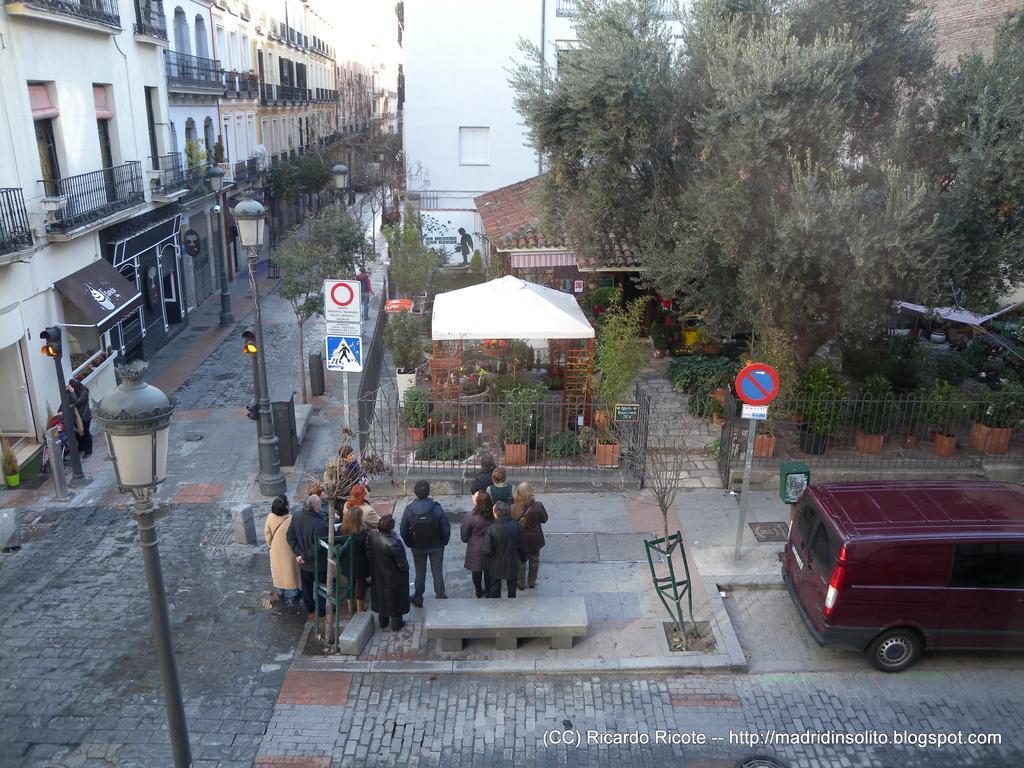In one or two sentences, can you explain what this image depicts? In this picture we can see a group of people standing, vehicle, poles, signboards, tent, sun shade, house plants, fence, lights, trees and in the background we can see buildings. 